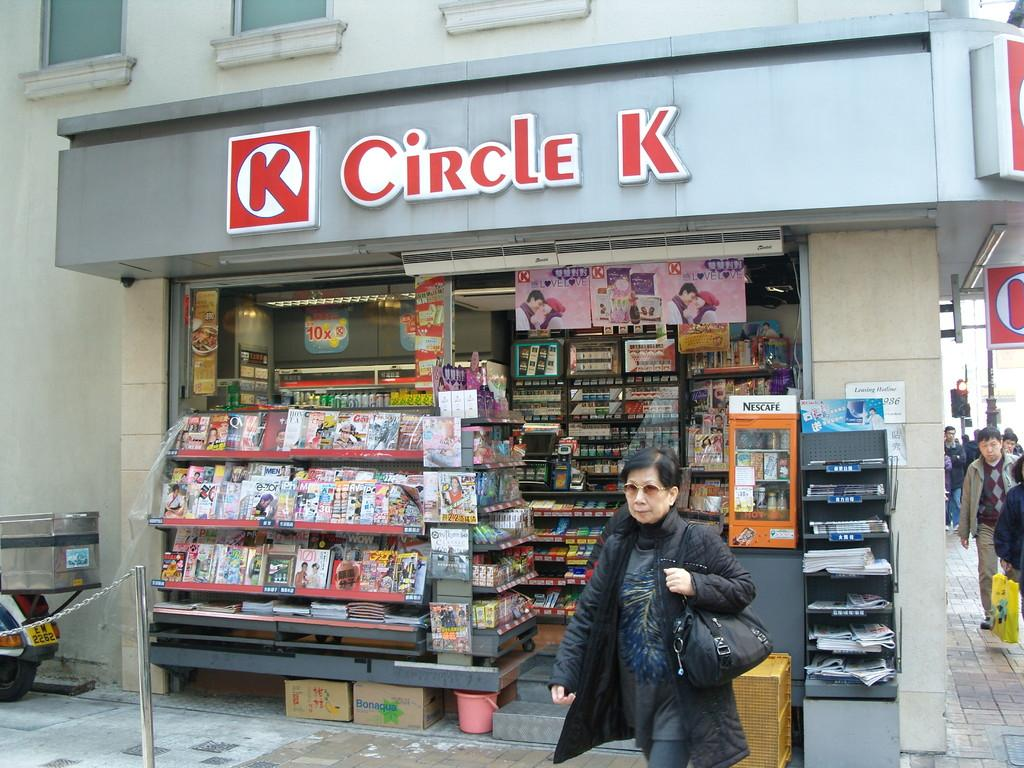<image>
Offer a succinct explanation of the picture presented. A woman in a coat walks out of a Circle K store. 